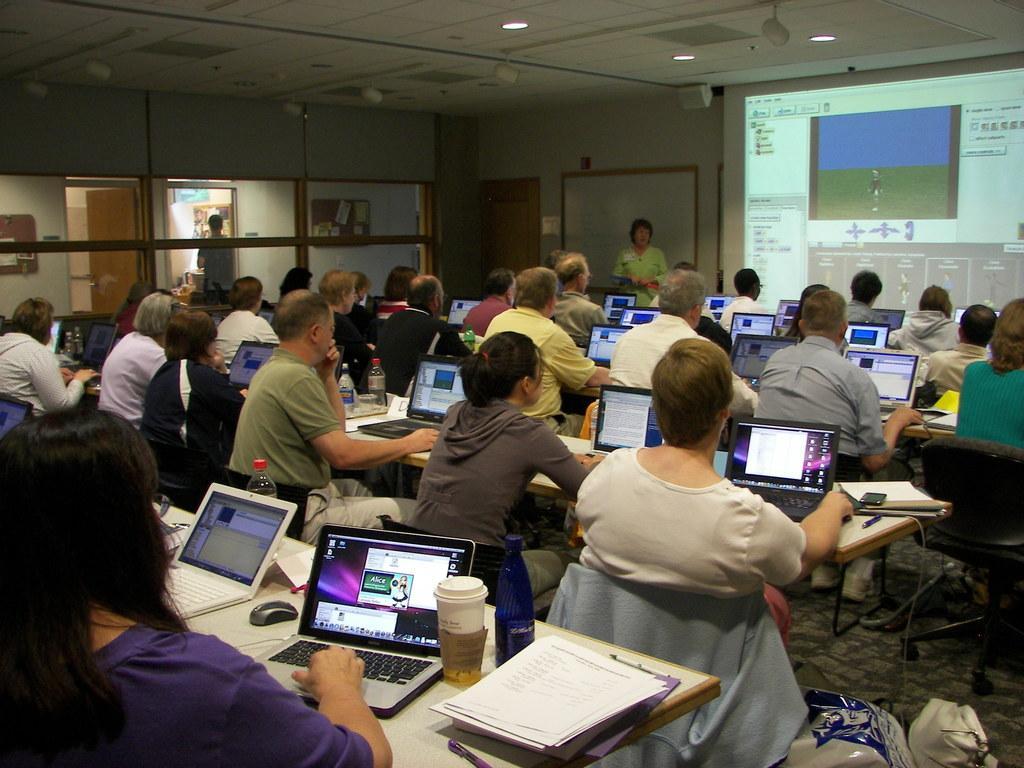Could you give a brief overview of what you see in this image? In the picture we can see a class room with some men and women near the tables and on it we can see laptops which are opened and they are working on it and in front of them we can see a woman standing and explaining something to them and behind her we can see a screen to the wall with some information focused on it to the ceiling we can see some lights. 